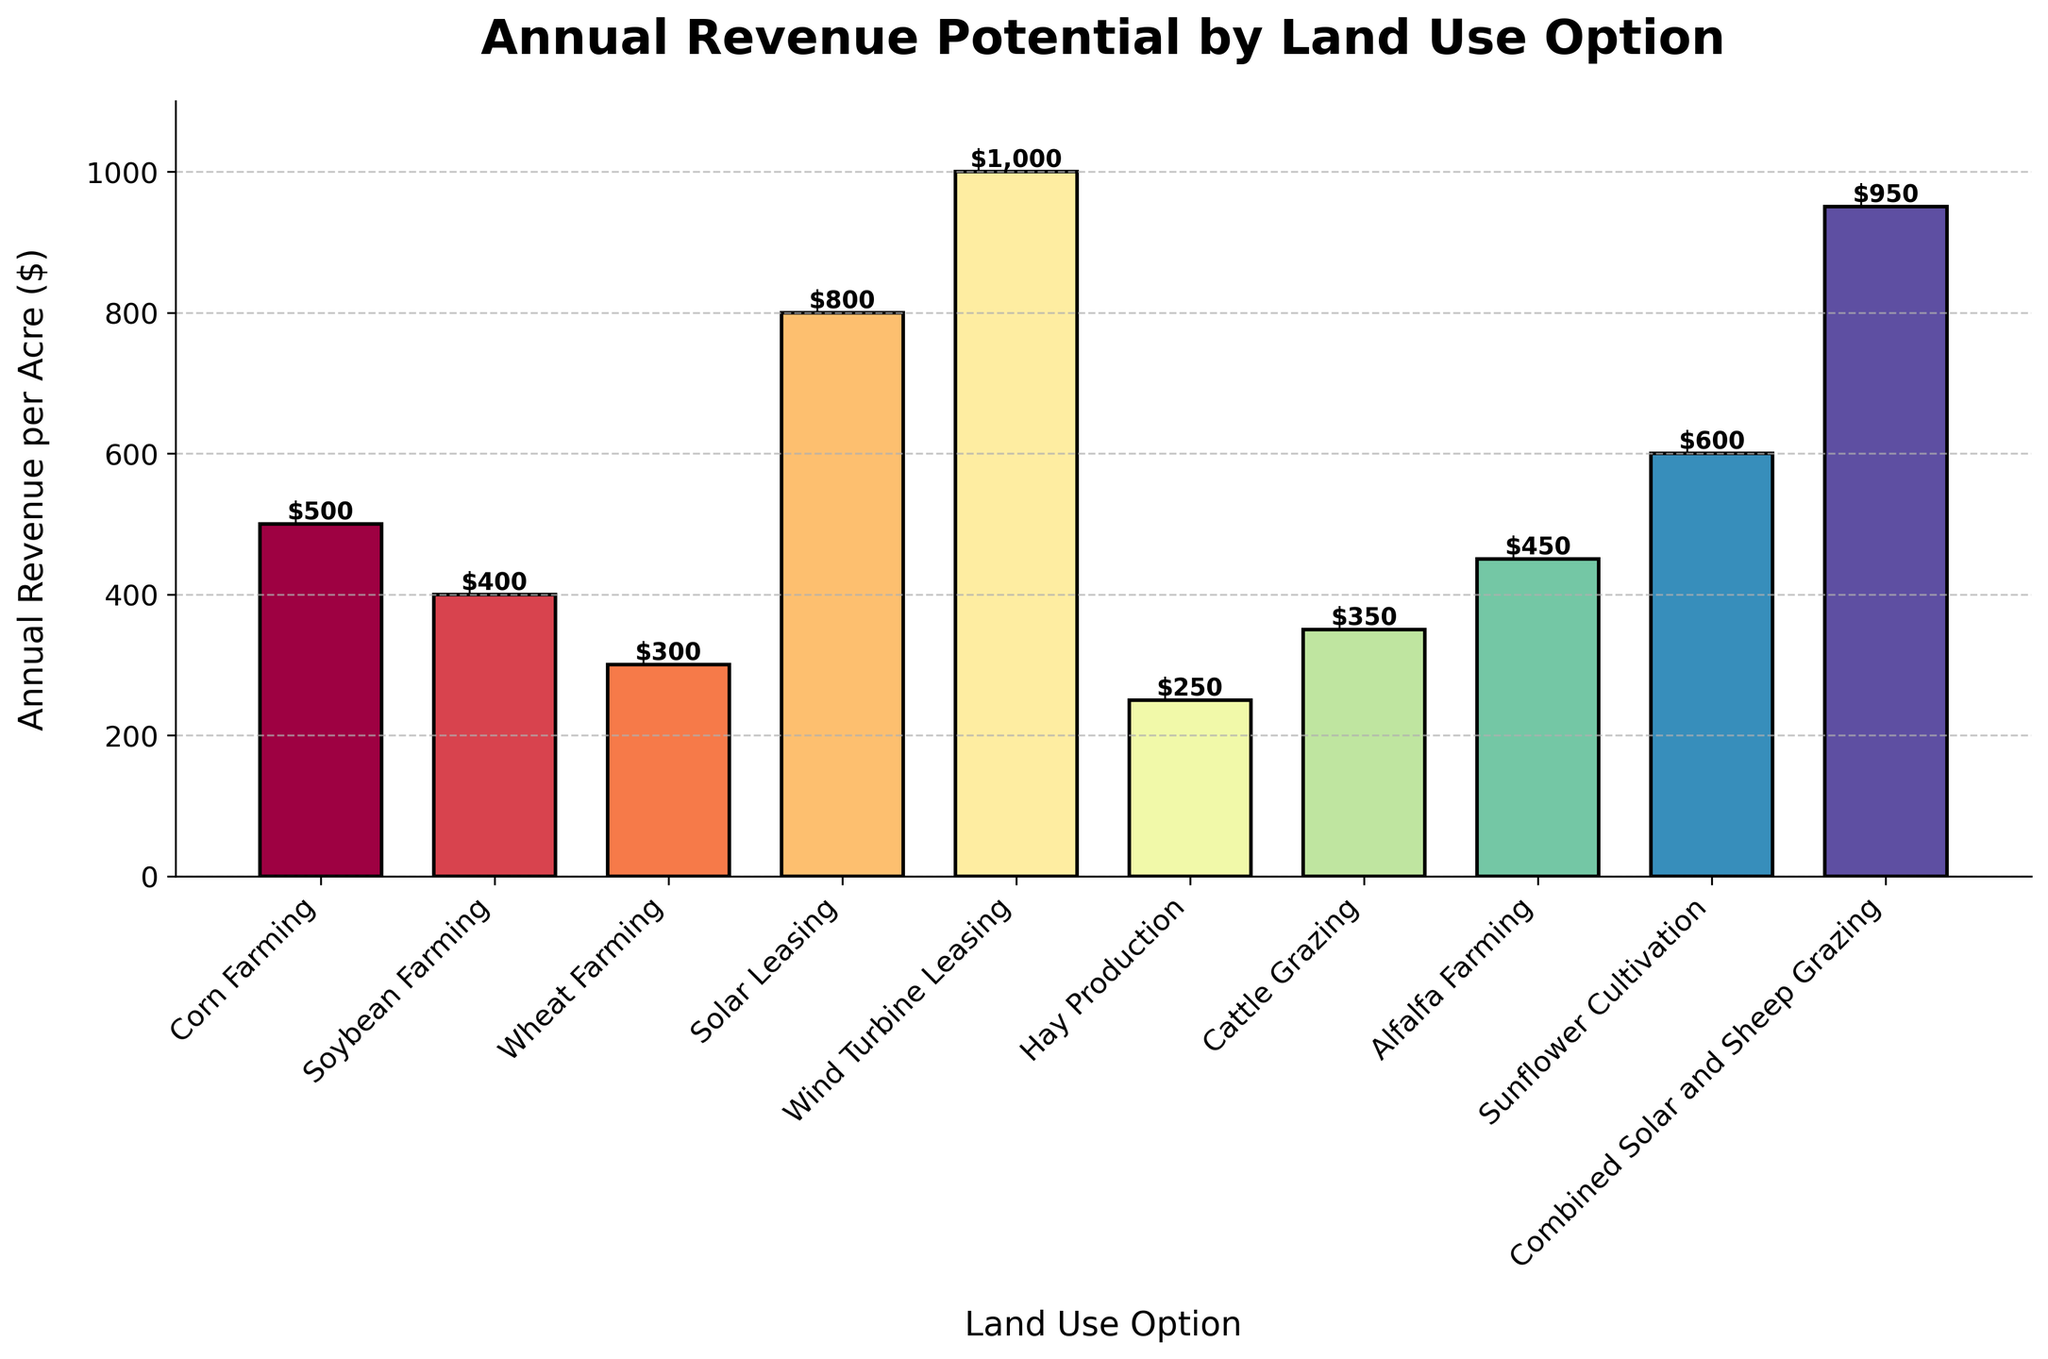What land use option has the highest annual revenue per acre? Identify the bar with the tallest height and the largest value label. The highest value is associated with "Wind Turbine Leasing," which has an annual revenue of $1,000 per acre.
Answer: Wind Turbine Leasing Which land use option has the lowest annual revenue per acre? Identify the bar with the shortest height and the smallest value label. The lowest value is associated with "Hay Production," which has an annual revenue of $250 per acre.
Answer: Hay Production What is the difference in annual revenue per acre between Solar Leasing and Corn Farming? Find the values for “Solar Leasing” ($800) and “Corn Farming” ($500) and subtract the latter from the former: $800 - $500 = $300.
Answer: $300 How much more annual revenue does Combined Solar and Sheep Grazing generate compared to Soybean Farming? Find the values for “Combined Solar and Sheep Grazing” ($950) and “Soybean Farming” ($400), then subtract to find the difference: $950 - $400 = $550.
Answer: $550 What is the average annual revenue per acre of all traditional farming options (Corn, Soybean, Wheat, Hay, Cattle, Alfalfa, Sunflower)? Sum the revenues: $500 + $400 + $300 + $250 + $350 + $450 + $600 = $2,850. Then divide by the number of options (7). Average = $2,850 / 7 ≈ $407.14.
Answer: $407.14 Are any options within $100 of Wind Turbine Leasing? Identify the annual revenue of "Wind Turbine Leasing" ($1,000) and see if any bars have values between $900 and $1,100. Only "Combined Solar and Sheep Grazing" with $950 fits within this range.
Answer: Combined Solar and Sheep Grazing What is the combined annual revenue per acre for traditional farming options (Corn, Soybean, Wheat, Hay, Cattle, Alfalfa, Sunflower)? Sum the revenues for Corn, Soybean, Wheat, Hay, Cattle, Alfalfa, and Sunflower: $500 + $400 + $300 + $250 + $350 + $450 + $600 = $2,850.
Answer: $2,850 Which land use options have a revenue per acre greater than $600? Identify bars with values higher than $600: "Combined Solar and Sheep Grazing" ($950), "Solar Leasing" ($800), and "Wind Turbine Leasing" ($1,000).
Answer: Combined Solar and Sheep Grazing, Solar Leasing, Wind Turbine Leasing Which land use option is visually represented by the most vibrant color? Describe the visual observation, typically the most vibrant or brightest color in the chart. This question is subjective but might refer to "Solar Leasing" or "Wind Turbine Leasing," as such categories often use more eye-catching colors in spectral palettes.
Answer: Solar Leasing or Wind Turbine Leasing What is the total annual revenue if you were to lease land for both Solar Leasing and Wind Turbine Leasing? Sum the revenues for "Solar Leasing" ($800) and "Wind Turbine Leasing" ($1,000): $800 + $1,000 = $1,800.
Answer: $1,800 